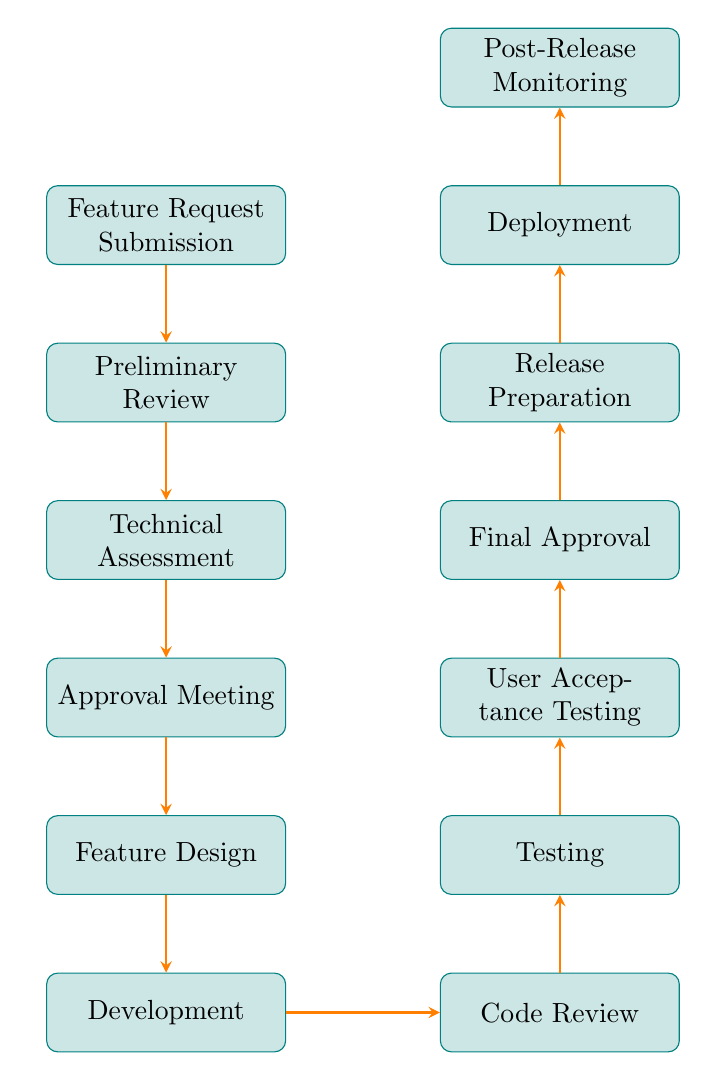What is the first node in the workflow? The flow chart starts with "Feature Request Submission," which is the first step in the workflow as seen at the top of the diagram.
Answer: Feature Request Submission How many nodes are there in total? By counting the individual steps represented in the diagram, there are 12 distinct nodes listed in the workflow, confirming there are 12 steps in total.
Answer: 12 What comes after the "Technical Assessment" node? Following "Technical Assessment" in the diagram, the next node is "Approval Meeting," indicating the workflow progression.
Answer: Approval Meeting Which node is directly linked to "User Acceptance Testing"? The node that follows "User Acceptance Testing" in the workflow is "Final Approval," showing the sequence of steps.
Answer: Final Approval Who evaluates the technical requirements? In the diagram, the "Lead Programmer" is responsible for assessing the technical requirements as indicated by the connection to the "Technical Assessment" node.
Answer: Lead Programmer What is the relationship between "Development" and "Code Review"? The relationship indicates that "Code Review" is the subsequent step that occurs after "Development," showcasing the sequence of actions in the flow.
Answer: Code Review Which node involves preparing release notes? The node responsible for preparing release notes is "Release Preparation," as seen in the workflow just before "Deployment."
Answer: Release Preparation How many steps are there from "Testing" to "Deployment"? Counting the steps from "Testing" to "Deployment," there are three steps in total: "Testing" to "User Acceptance Testing," "User Acceptance Testing" to "Final Approval," and "Final Approval" to "Release Preparation," and finally "Release Preparation" to "Deployment."
Answer: 4 What is the last step in the feature request workflow? According to the flow chart, the last step in the feature request workflow is "Post-Release Monitoring," which concludes the process.
Answer: Post-Release Monitoring 